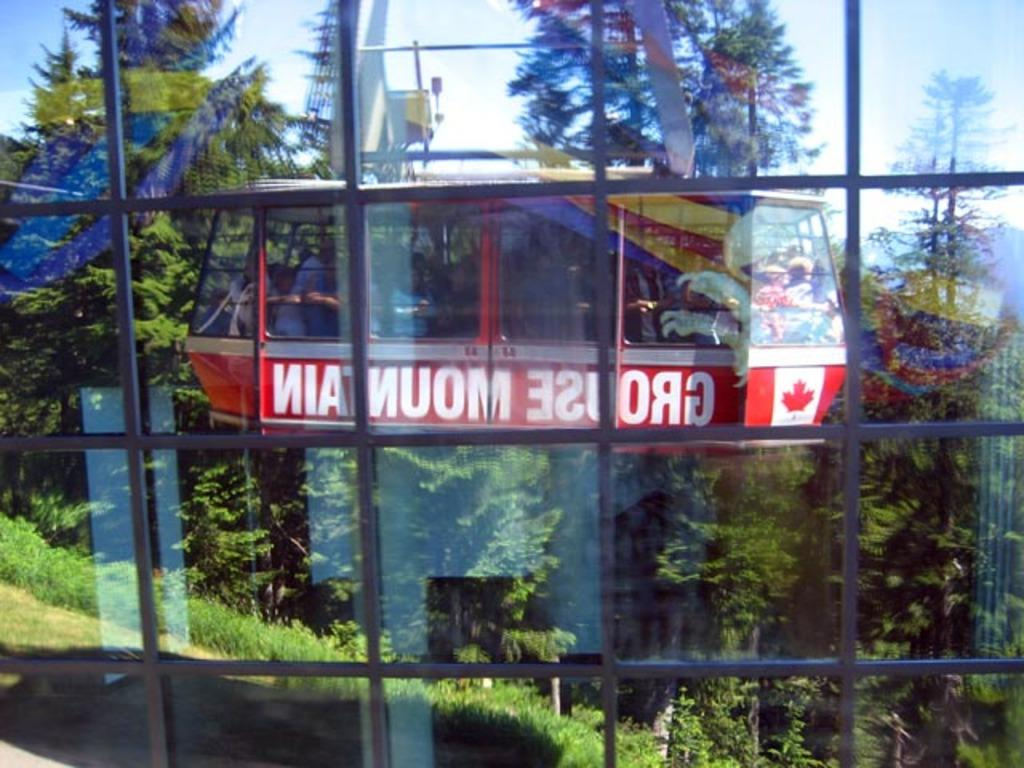<image>
Render a clear and concise summary of the photo. Red object with the word MOUNTAIn as well as a Canadian flag on it. 